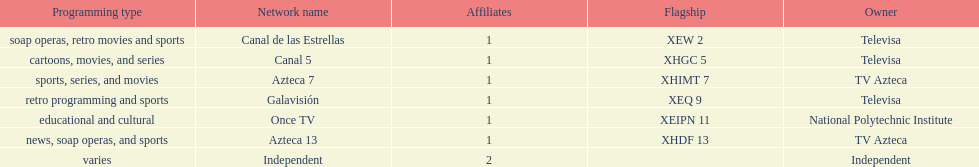Who are the owners of the stations listed here? Televisa, Televisa, TV Azteca, Televisa, National Polytechnic Institute, TV Azteca, Independent. What is the one station owned by national polytechnic institute? Once TV. 